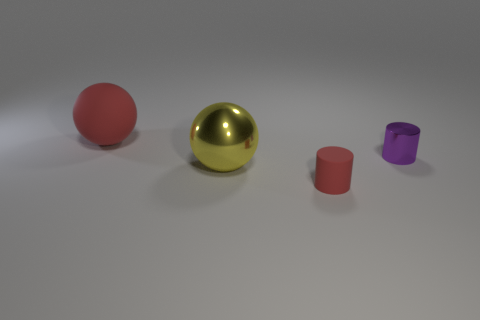There is a big sphere on the left side of the shiny sphere; is it the same color as the small thing that is in front of the purple cylinder?
Offer a terse response. Yes. There is a metallic ball that is the same size as the rubber sphere; what color is it?
Your response must be concise. Yellow. Is there a shiny object that has the same color as the shiny cylinder?
Offer a terse response. No. Do the red object that is in front of the purple object and the yellow ball have the same size?
Keep it short and to the point. No. Are there an equal number of big yellow objects in front of the big yellow shiny object and large matte objects?
Keep it short and to the point. No. How many things are either yellow metal spheres that are to the right of the red rubber sphere or blue rubber balls?
Make the answer very short. 1. The object that is both in front of the purple cylinder and on the left side of the tiny red matte cylinder has what shape?
Make the answer very short. Sphere. How many objects are either cylinders in front of the metal sphere or matte things in front of the small purple metallic object?
Your answer should be compact. 1. What number of other objects are there of the same size as the red sphere?
Your answer should be compact. 1. Does the rubber thing that is behind the big shiny thing have the same color as the shiny ball?
Offer a very short reply. No. 